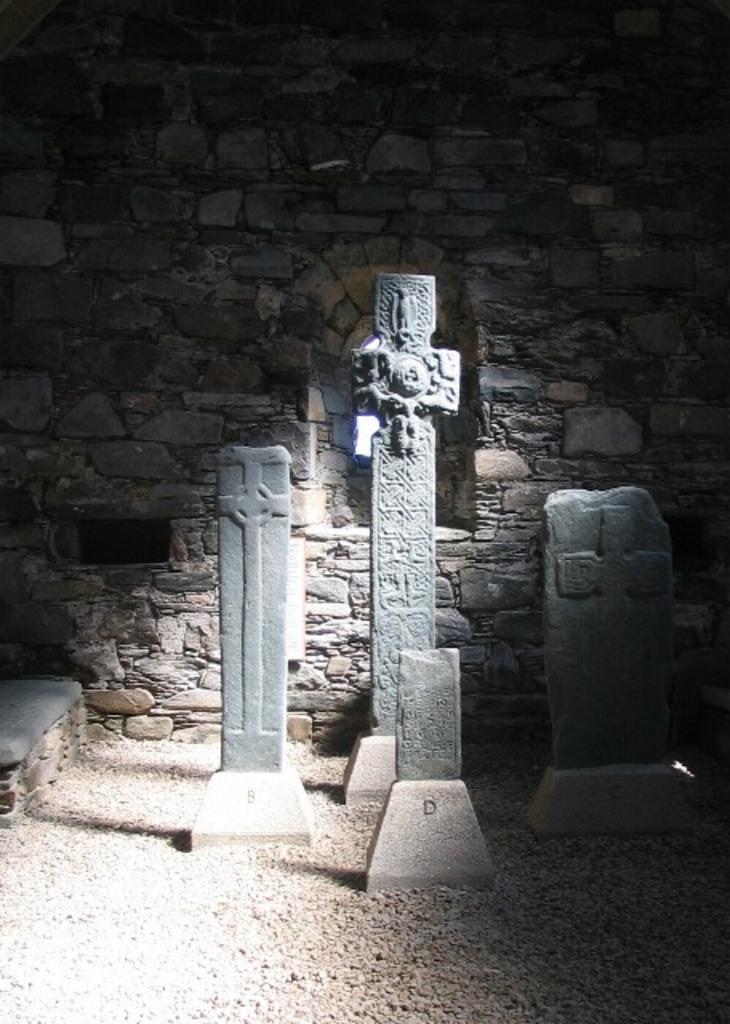Could you give a brief overview of what you see in this image? In this picture there are sculptures of the cross. At the back there is a wall. At the bottom there are stones. 